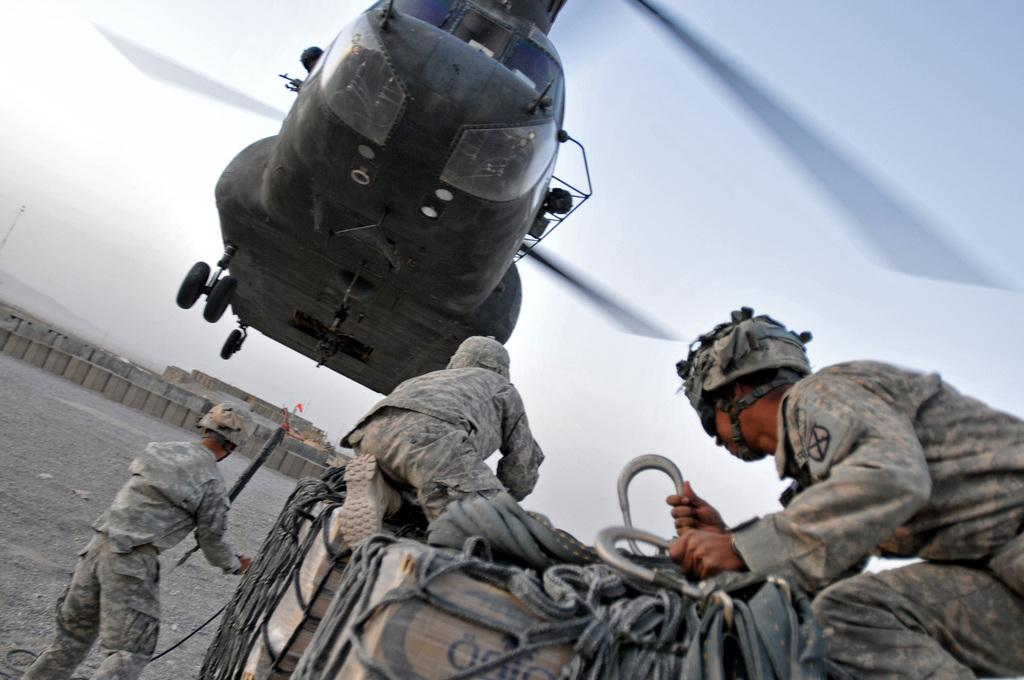What is the main subject of the image? The main subject of the image is an aircraft. Can you describe the people in the image? There are people in the image, but their specific actions or roles are not clear from the facts provided. What can be seen in the sky in the image? The sky is visible in the image, but no specific weather conditions or celestial bodies are mentioned. What is the purpose of the barrier in the image? The purpose of the barrier in the image is not clear from the facts provided. What type of structure is the house in the image? The type of structure or architectural style of the house in the image is not mentioned in the facts provided. What type of riddle is being solved by the people in the image? There is no indication in the image that the people are solving a riddle or engaging in any specific activity. How does the education system in the image differ from the one in the real world? The facts provided do not mention any educational elements or systems, so it is not possible to compare them to the real world. 